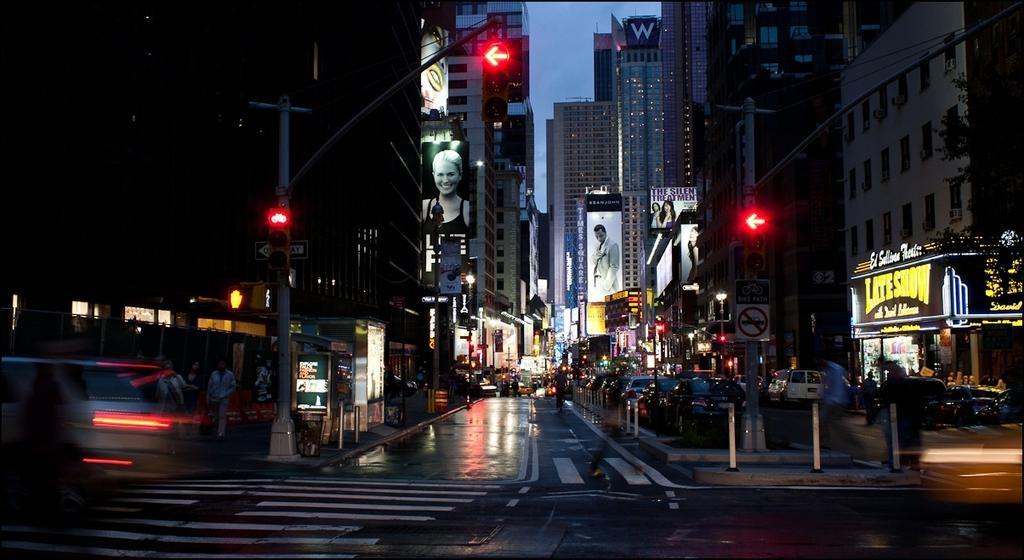Please provide a concise description of this image. This is an image clicked in the dark. At the bottom there is a road. On both sides of the road there are many poles and buildings. Here I can see many vehicles on the road. In the background there are many lights. At the top of the image I can see the sky. 